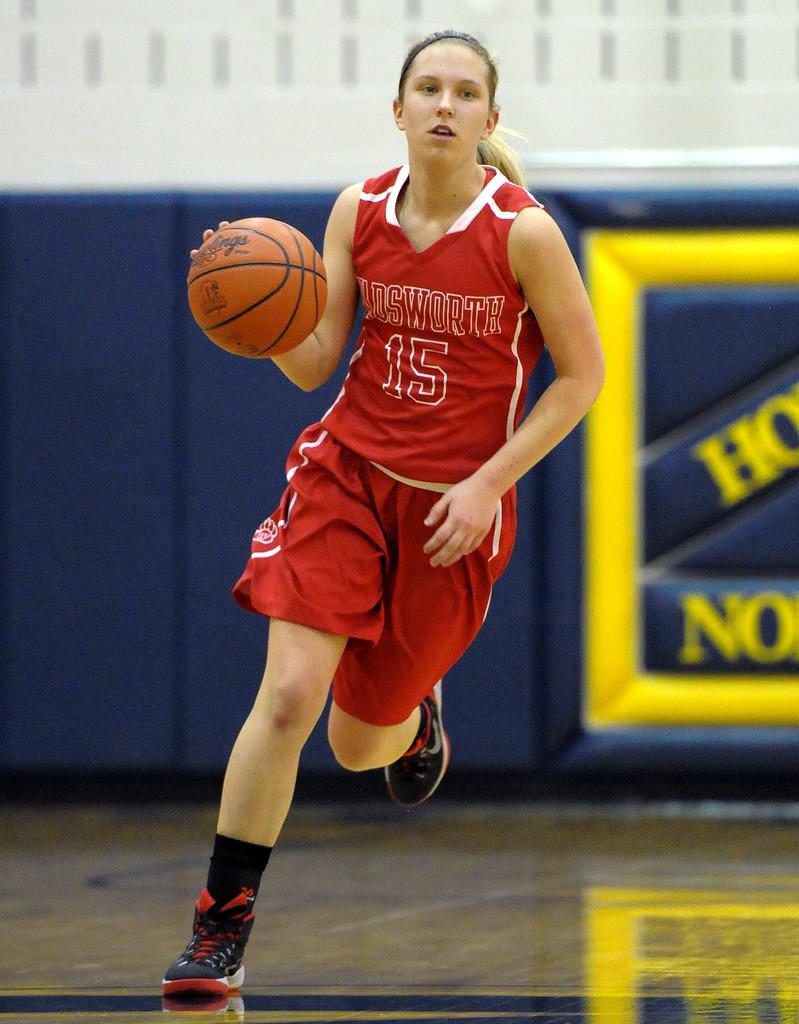<image>
Relay a brief, clear account of the picture shown. Basketball player number 15 has the ball and is running. 